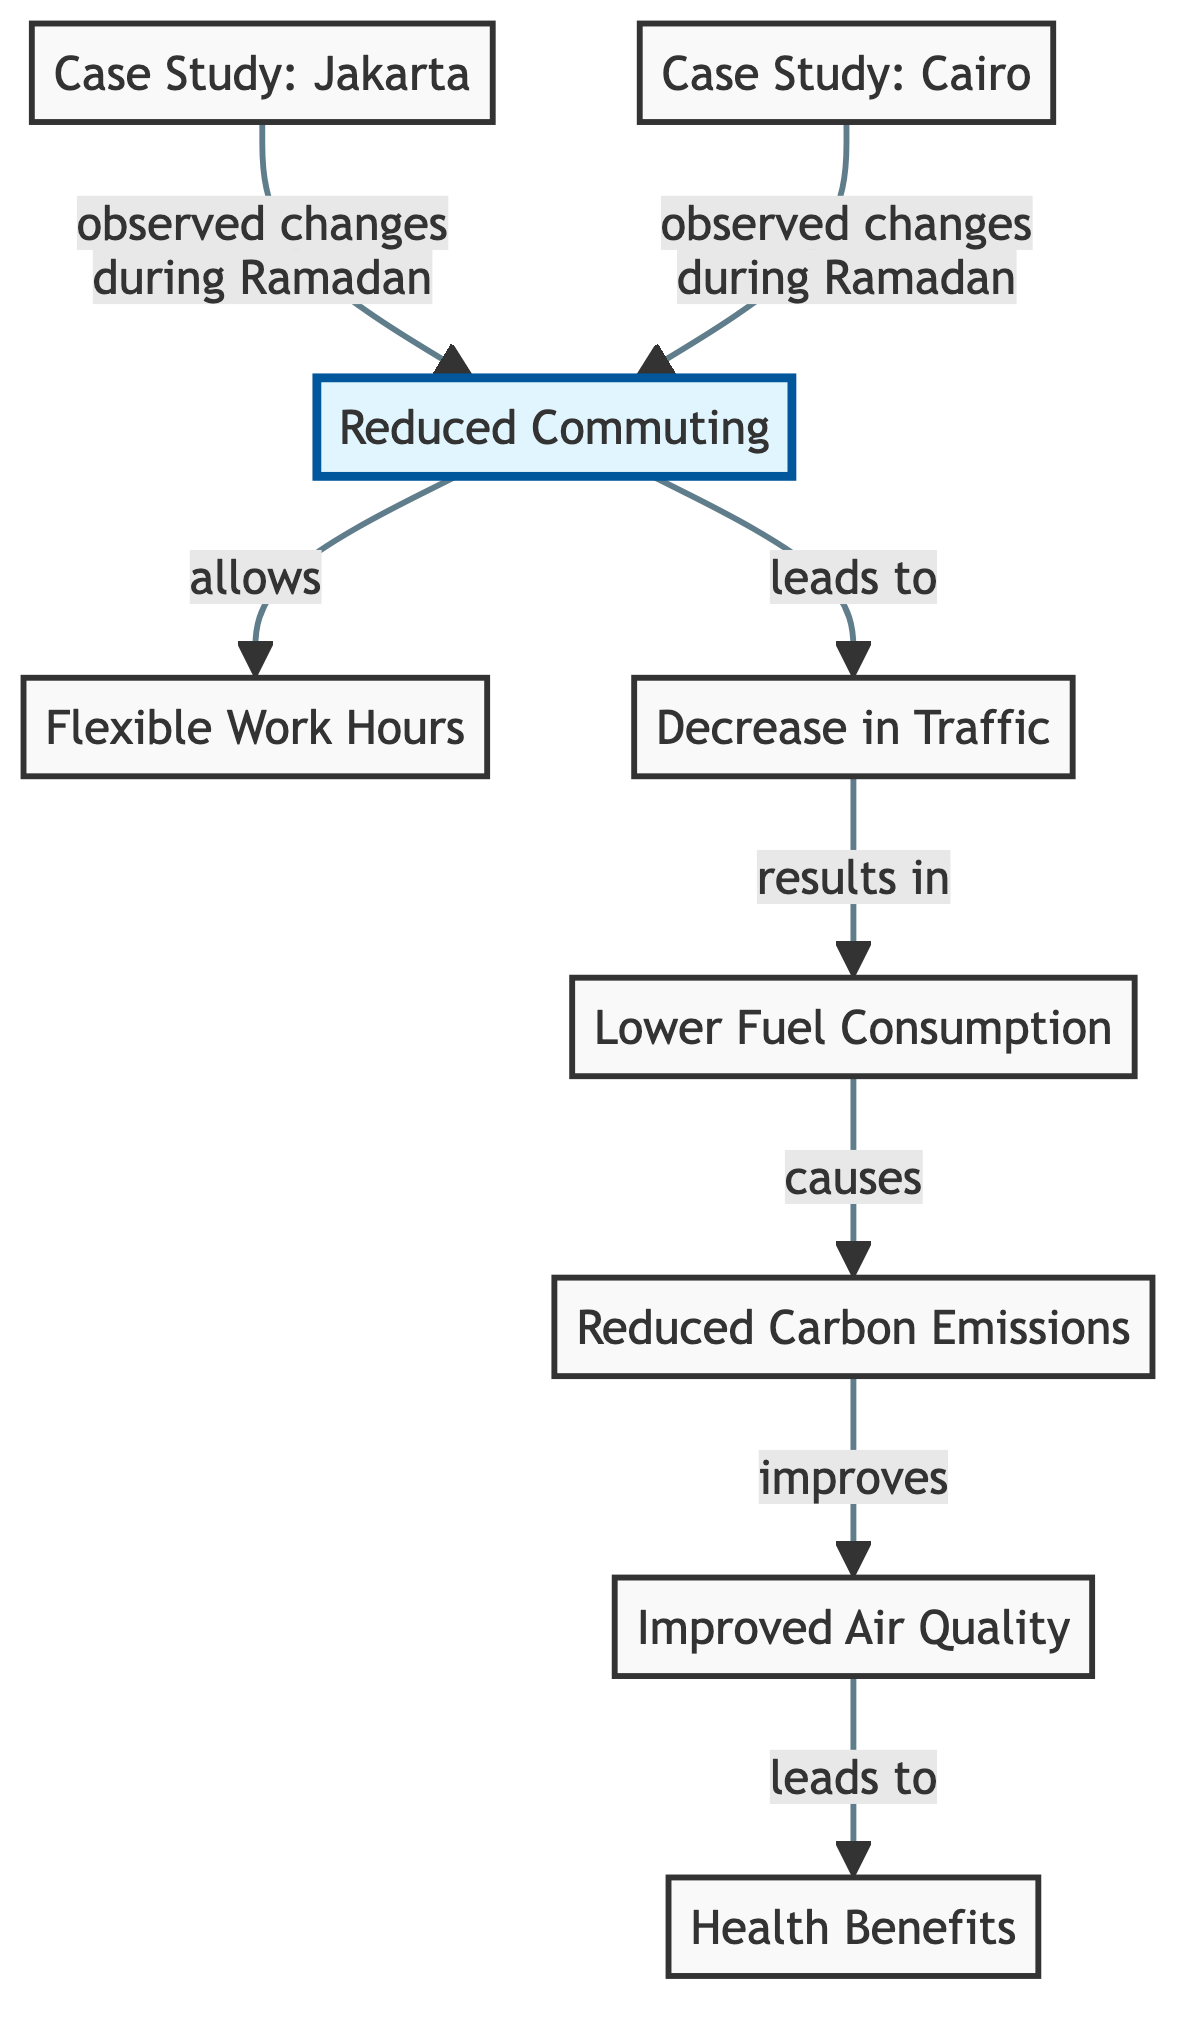What is the first node in the diagram? The first node is "Reduced Commuting," which initiates the flow of the diagram.
Answer: Reduced Commuting How many case studies are mentioned in the diagram? There are two case studies listed: one for Jakarta and one for Cairo.
Answer: 2 What does "Reduced Commuting" lead to? "Reduced Commuting" leads to the node "Flexible Work Hours," indicating this is a direct outcome of reduced commuting.
Answer: Flexible Work Hours What is the last node in the diagram? The last node is "Health Benefits," which indicates positive outcomes resulting from improved air quality.
Answer: Health Benefits Which node is connected to both Jakarta and Cairo case studies? The node "Reduced Commuting" is connected to both, indicating its relevance to observed changes in these cities during Ramadan.
Answer: Reduced Commuting What is the relationship between "Lower Fuel Consumption" and "Reduced Carbon Emissions"? "Lower Fuel Consumption" causes "Reduced Carbon Emissions," suggesting the environmental benefits that follow from decreased fuel usage.
Answer: causes What node improves as a result of reduced carbon emissions? "Improved Air Quality" improves as a direct result of reduced carbon emissions, showing the positive environmental impact.
Answer: Improved Air Quality How many arrows point out from the "Decrease in Traffic" node? There is one arrow pointed out from the "Decrease in Traffic" node, leading directly to "Lower Fuel Consumption."
Answer: 1 What do the case studies indicate about commuting patterns during Ramadan? The case studies indicate "observed changes during Ramadan," highlighting the effects of the holy month on commuting habits in the specified cities.
Answer: observed changes during Ramadan 